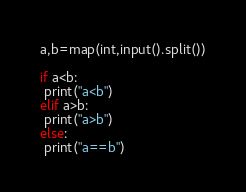<code> <loc_0><loc_0><loc_500><loc_500><_Python_>a,b=map(int,input().split())

if a<b:
 print("a<b")
elif a>b:
 print("a>b")
else:
 print("a==b")</code> 